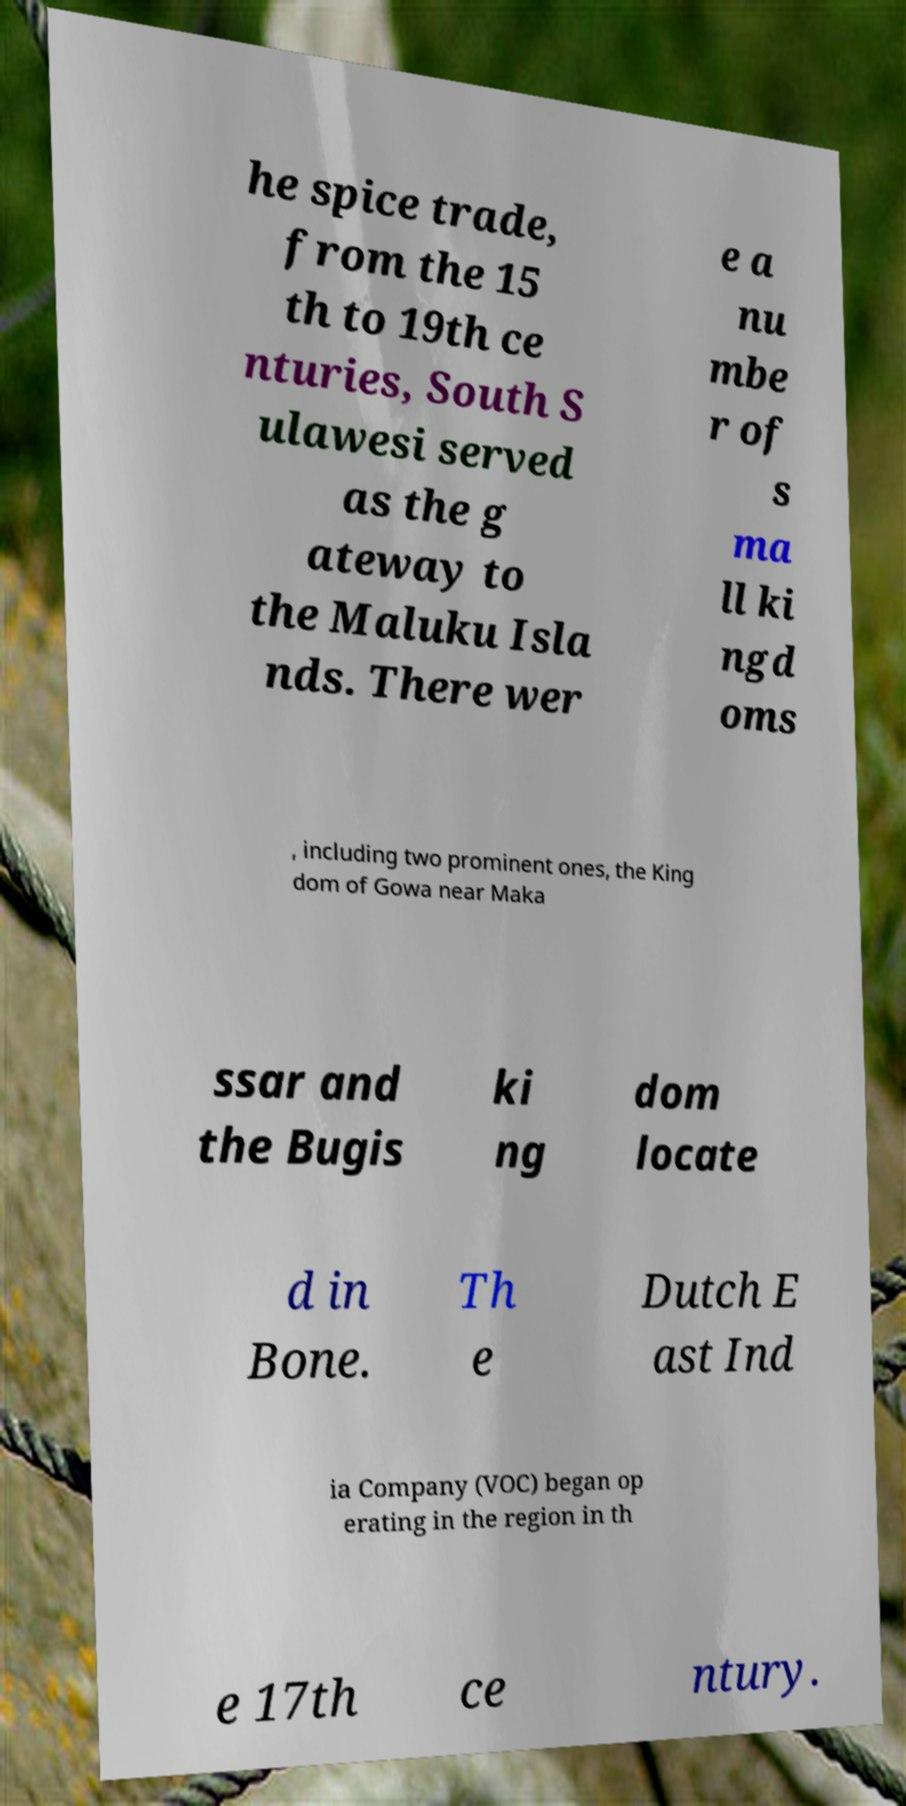Please identify and transcribe the text found in this image. he spice trade, from the 15 th to 19th ce nturies, South S ulawesi served as the g ateway to the Maluku Isla nds. There wer e a nu mbe r of s ma ll ki ngd oms , including two prominent ones, the King dom of Gowa near Maka ssar and the Bugis ki ng dom locate d in Bone. Th e Dutch E ast Ind ia Company (VOC) began op erating in the region in th e 17th ce ntury. 